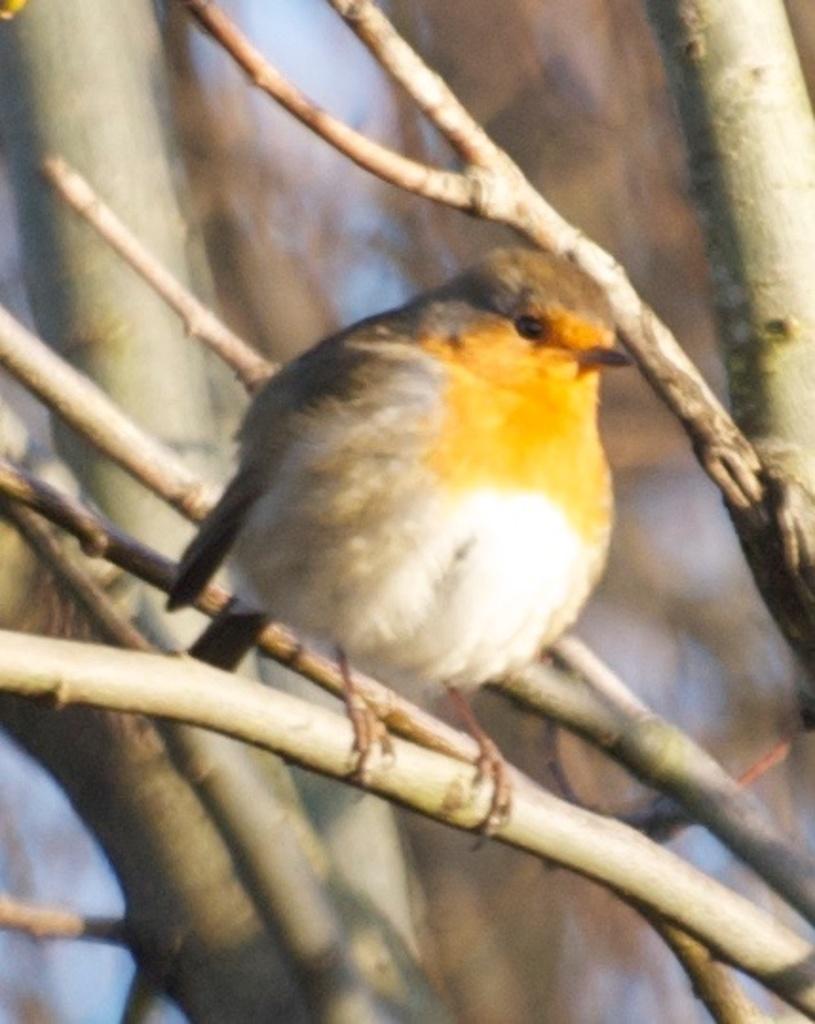How would you summarize this image in a sentence or two? In the center of the image we can see bird on the tree. In the background there are trees. 